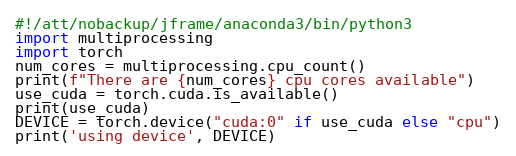Convert code to text. <code><loc_0><loc_0><loc_500><loc_500><_Python_>#!/att/nobackup/jframe/anaconda3/bin/python3
import multiprocessing
import torch
num_cores = multiprocessing.cpu_count()
print(f"There are {num_cores} cpu cores available")
use_cuda = torch.cuda.is_available()
print(use_cuda)
DEVICE = torch.device("cuda:0" if use_cuda else "cpu")
print('using device', DEVICE)
</code> 